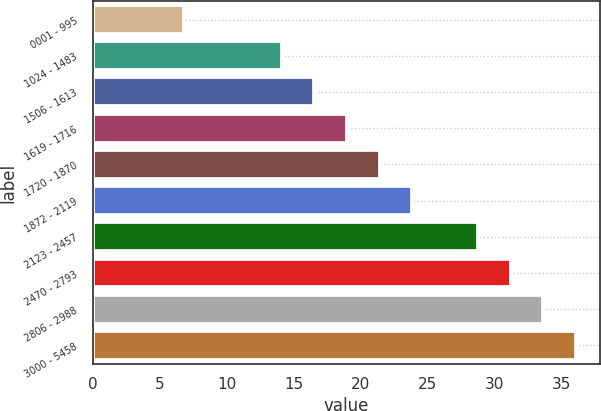<chart> <loc_0><loc_0><loc_500><loc_500><bar_chart><fcel>0001 - 995<fcel>1024 - 1483<fcel>1506 - 1613<fcel>1619 - 1716<fcel>1720 - 1870<fcel>1872 - 2119<fcel>2123 - 2457<fcel>2470 - 2793<fcel>2806 - 2988<fcel>3000 - 5458<nl><fcel>6.83<fcel>14.11<fcel>16.55<fcel>19<fcel>21.45<fcel>23.89<fcel>28.79<fcel>31.23<fcel>33.67<fcel>36.12<nl></chart> 